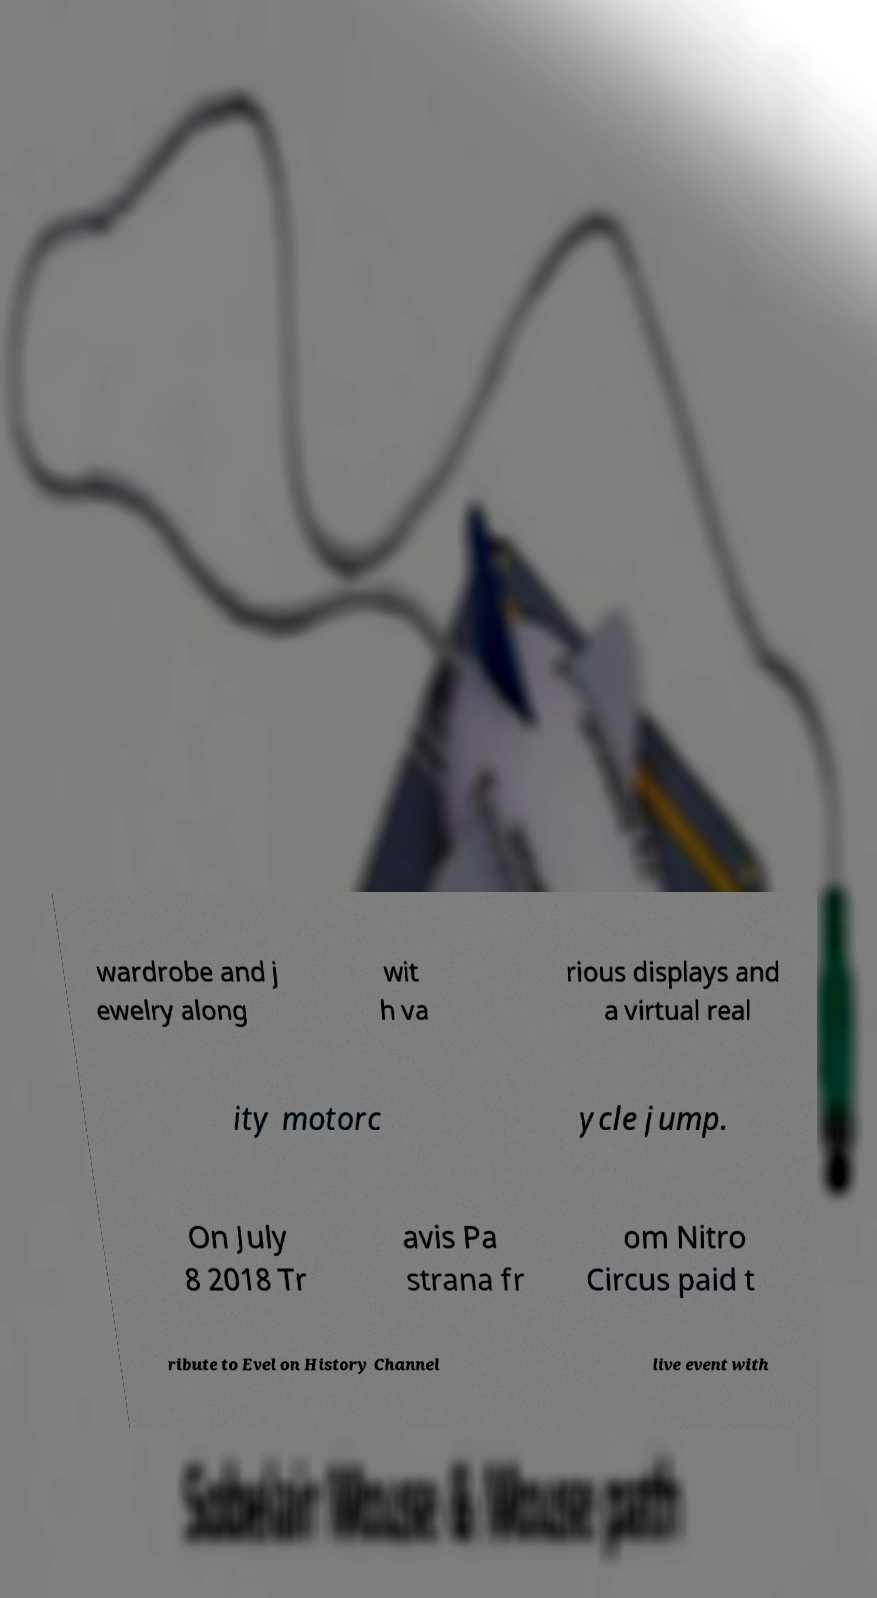I need the written content from this picture converted into text. Can you do that? wardrobe and j ewelry along wit h va rious displays and a virtual real ity motorc ycle jump. On July 8 2018 Tr avis Pa strana fr om Nitro Circus paid t ribute to Evel on History Channel live event with 